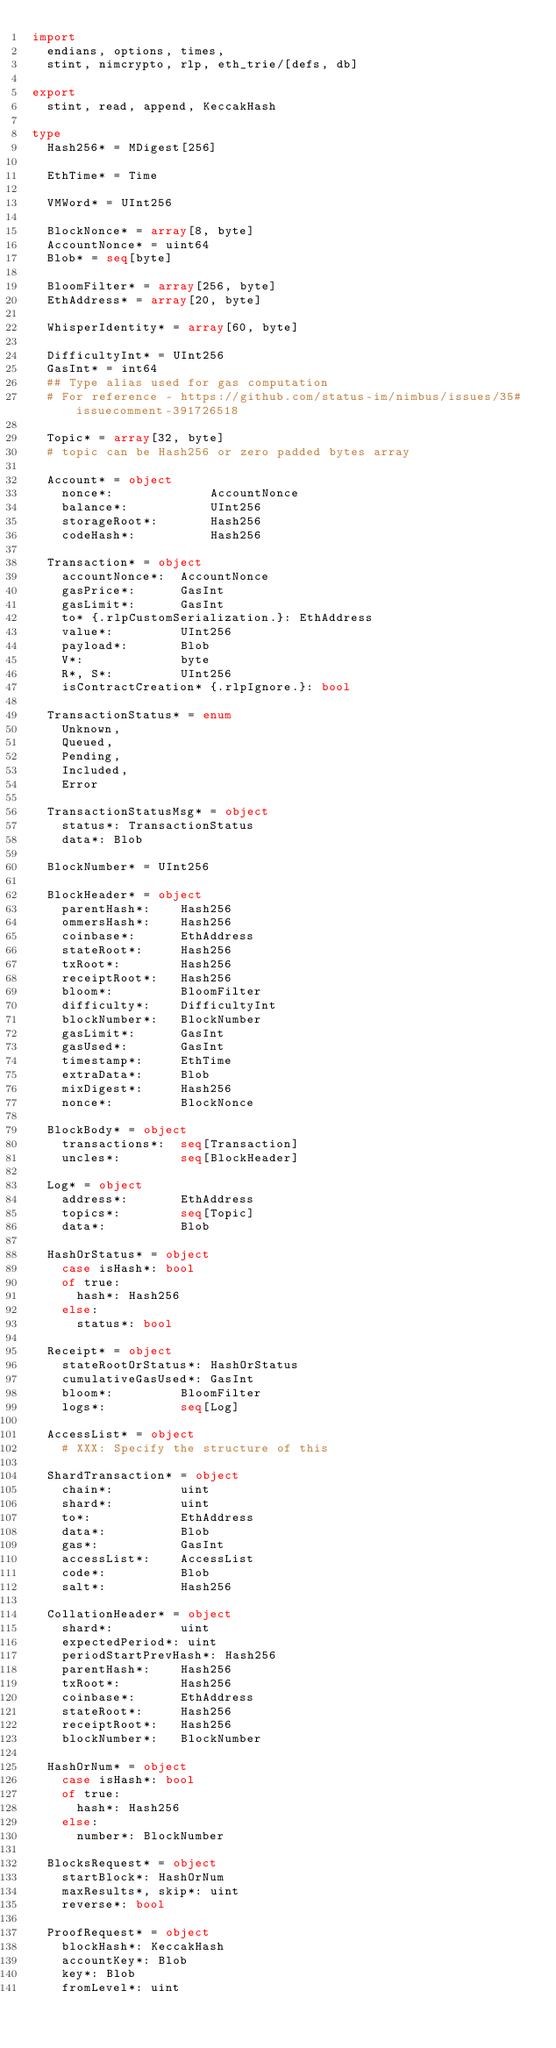Convert code to text. <code><loc_0><loc_0><loc_500><loc_500><_Nim_>import
  endians, options, times,
  stint, nimcrypto, rlp, eth_trie/[defs, db]

export
  stint, read, append, KeccakHash

type
  Hash256* = MDigest[256]

  EthTime* = Time

  VMWord* = UInt256

  BlockNonce* = array[8, byte]
  AccountNonce* = uint64
  Blob* = seq[byte]

  BloomFilter* = array[256, byte]
  EthAddress* = array[20, byte]

  WhisperIdentity* = array[60, byte]

  DifficultyInt* = UInt256
  GasInt* = int64
  ## Type alias used for gas computation
  # For reference - https://github.com/status-im/nimbus/issues/35#issuecomment-391726518

  Topic* = array[32, byte]
  # topic can be Hash256 or zero padded bytes array

  Account* = object
    nonce*:             AccountNonce
    balance*:           UInt256
    storageRoot*:       Hash256
    codeHash*:          Hash256

  Transaction* = object
    accountNonce*:  AccountNonce
    gasPrice*:      GasInt
    gasLimit*:      GasInt
    to* {.rlpCustomSerialization.}: EthAddress
    value*:         UInt256
    payload*:       Blob
    V*:             byte
    R*, S*:         UInt256
    isContractCreation* {.rlpIgnore.}: bool

  TransactionStatus* = enum
    Unknown,
    Queued,
    Pending,
    Included,
    Error

  TransactionStatusMsg* = object
    status*: TransactionStatus
    data*: Blob

  BlockNumber* = UInt256

  BlockHeader* = object
    parentHash*:    Hash256
    ommersHash*:    Hash256
    coinbase*:      EthAddress
    stateRoot*:     Hash256
    txRoot*:        Hash256
    receiptRoot*:   Hash256
    bloom*:         BloomFilter
    difficulty*:    DifficultyInt
    blockNumber*:   BlockNumber
    gasLimit*:      GasInt
    gasUsed*:       GasInt
    timestamp*:     EthTime
    extraData*:     Blob
    mixDigest*:     Hash256
    nonce*:         BlockNonce

  BlockBody* = object
    transactions*:  seq[Transaction]
    uncles*:        seq[BlockHeader]

  Log* = object
    address*:       EthAddress
    topics*:        seq[Topic]
    data*:          Blob

  HashOrStatus* = object
    case isHash*: bool
    of true:
      hash*: Hash256
    else:
      status*: bool

  Receipt* = object
    stateRootOrStatus*: HashOrStatus
    cumulativeGasUsed*: GasInt
    bloom*:         BloomFilter
    logs*:          seq[Log]

  AccessList* = object
    # XXX: Specify the structure of this

  ShardTransaction* = object
    chain*:         uint
    shard*:         uint
    to*:            EthAddress
    data*:          Blob
    gas*:           GasInt
    accessList*:    AccessList
    code*:          Blob
    salt*:          Hash256

  CollationHeader* = object
    shard*:         uint
    expectedPeriod*: uint
    periodStartPrevHash*: Hash256
    parentHash*:    Hash256
    txRoot*:        Hash256
    coinbase*:      EthAddress
    stateRoot*:     Hash256
    receiptRoot*:   Hash256
    blockNumber*:   BlockNumber

  HashOrNum* = object
    case isHash*: bool
    of true:
      hash*: Hash256
    else:
      number*: BlockNumber

  BlocksRequest* = object
    startBlock*: HashOrNum
    maxResults*, skip*: uint
    reverse*: bool

  ProofRequest* = object
    blockHash*: KeccakHash
    accountKey*: Blob
    key*: Blob
    fromLevel*: uint
</code> 